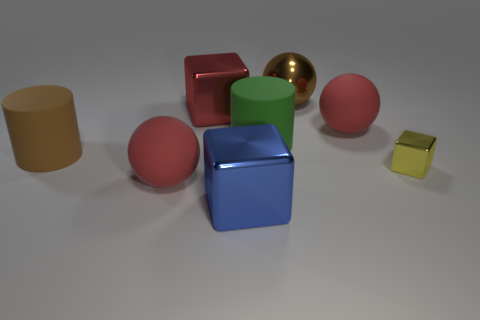Are there any other things that have the same size as the yellow cube?
Make the answer very short. No. There is a red sphere on the left side of the green object; is there a brown cylinder that is behind it?
Provide a succinct answer. Yes. Are there fewer large blue spheres than large red spheres?
Make the answer very short. Yes. What number of tiny yellow objects have the same shape as the red metallic object?
Provide a short and direct response. 1. How many blue objects are large rubber cubes or matte cylinders?
Give a very brief answer. 0. There is a cube in front of the ball in front of the brown rubber cylinder; how big is it?
Make the answer very short. Large. What material is the brown thing that is the same shape as the large green thing?
Offer a terse response. Rubber. What number of blue things have the same size as the brown shiny sphere?
Your answer should be very brief. 1. Do the yellow metallic block and the red cube have the same size?
Provide a short and direct response. No. What size is the thing that is right of the brown metal object and in front of the green object?
Offer a terse response. Small. 